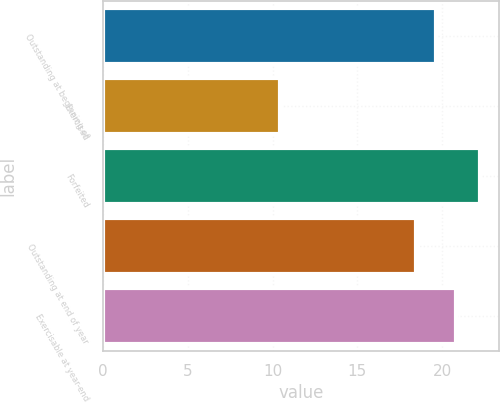<chart> <loc_0><loc_0><loc_500><loc_500><bar_chart><fcel>Outstanding at beginning of<fcel>Exercised<fcel>Forfeited<fcel>Outstanding at end of year<fcel>Exercisable at year-end<nl><fcel>19.63<fcel>10.42<fcel>22.24<fcel>18.45<fcel>20.81<nl></chart> 